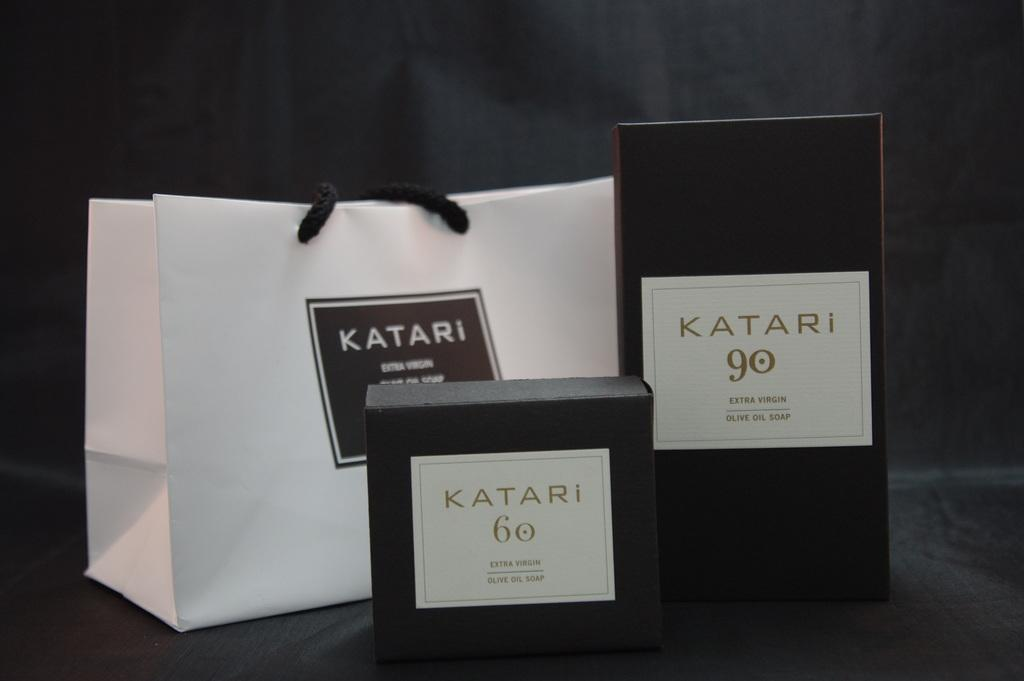What objects are present in the image? There are boxes and a bag with text in the image. What can be seen on the bag? The bag has numbers on it. What is visible behind the objects in the image? There is a background visible in the image. How many parcels are stacked on the wall in the image? There is no wall or parcel present in the image. What type of receipt can be seen next to the bag in the image? There is no receipt visible in the image. 